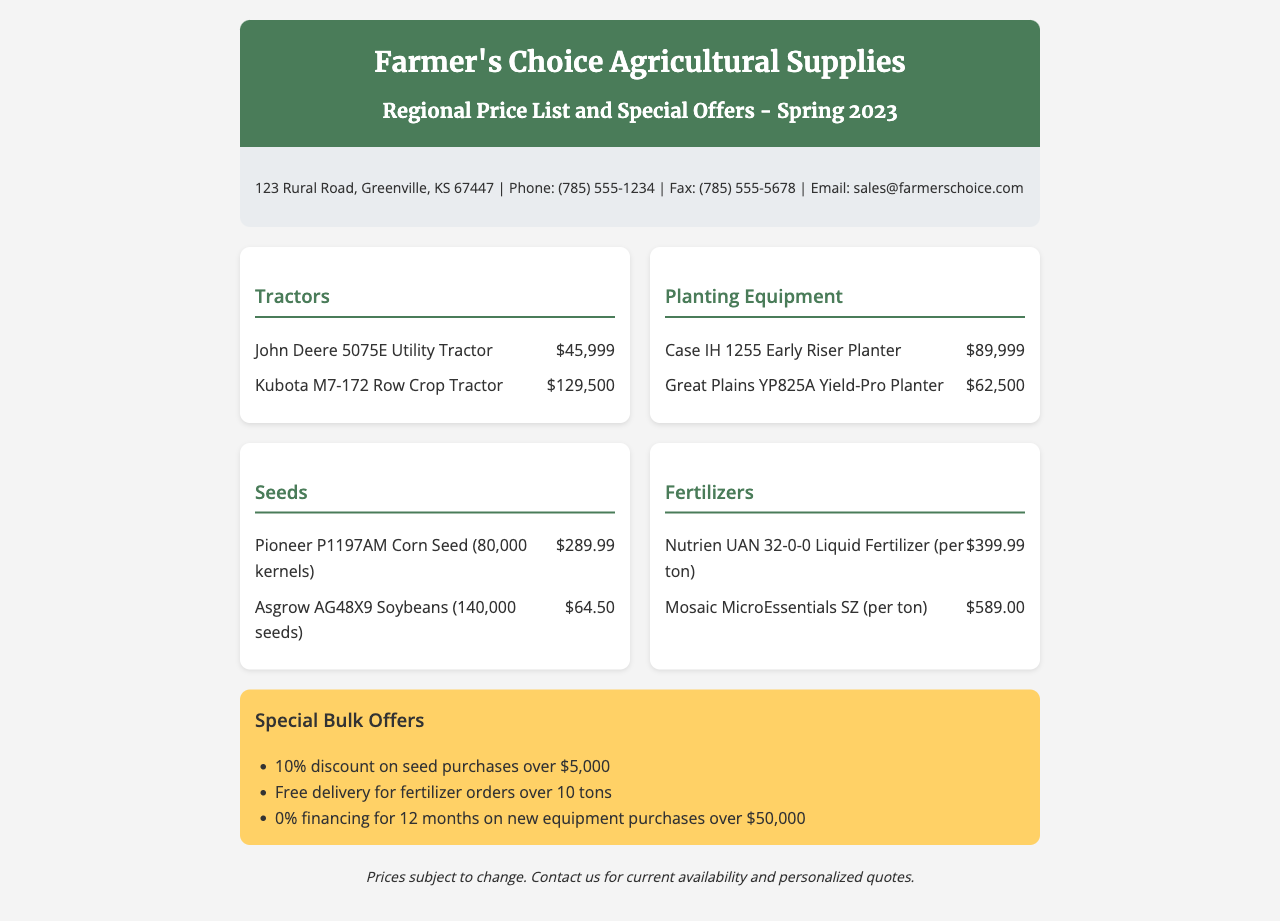What is the price of the John Deere 5075E Utility Tractor? The price of the John Deere 5075E Utility Tractor is listed in the document.
Answer: $45,999 How many seeds are in a bag of Asgrow AG48X9 Soybeans? The document specifies the quantity of seeds in a bag of Asgrow AG48X9 Soybeans.
Answer: 140,000 seeds What bulk discount is offered on seed purchases over $5,000? The document lists the bulk discount for seed purchases over $5,000.
Answer: 10% discount Who is the distributor mentioned in the document? The name of the distributor is provided at the top of the document.
Answer: Farmer's Choice Agricultural Supplies What type of fertilizer has a price of $399.99? The document indicates the specific fertilizer and its price.
Answer: Nutrien UAN 32-0-0 Liquid Fertilizer What is the financing period offered on new equipment purchases over $50,000? The document specifies the financing period available for new equipment purchases.
Answer: 12 months How many tons must fertilizer orders exceed to qualify for free delivery? The document provides the required quantity for free delivery on fertilizer orders.
Answer: 10 tons What is the email contact for Farmer's Choice? The document includes the distributor's email contact information.
Answer: sales@farmerschoice.com What is the location of Farmer's Choice Agricultural Supplies? The document states the physical address of the distributor.
Answer: 123 Rural Road, Greenville, KS 67447 